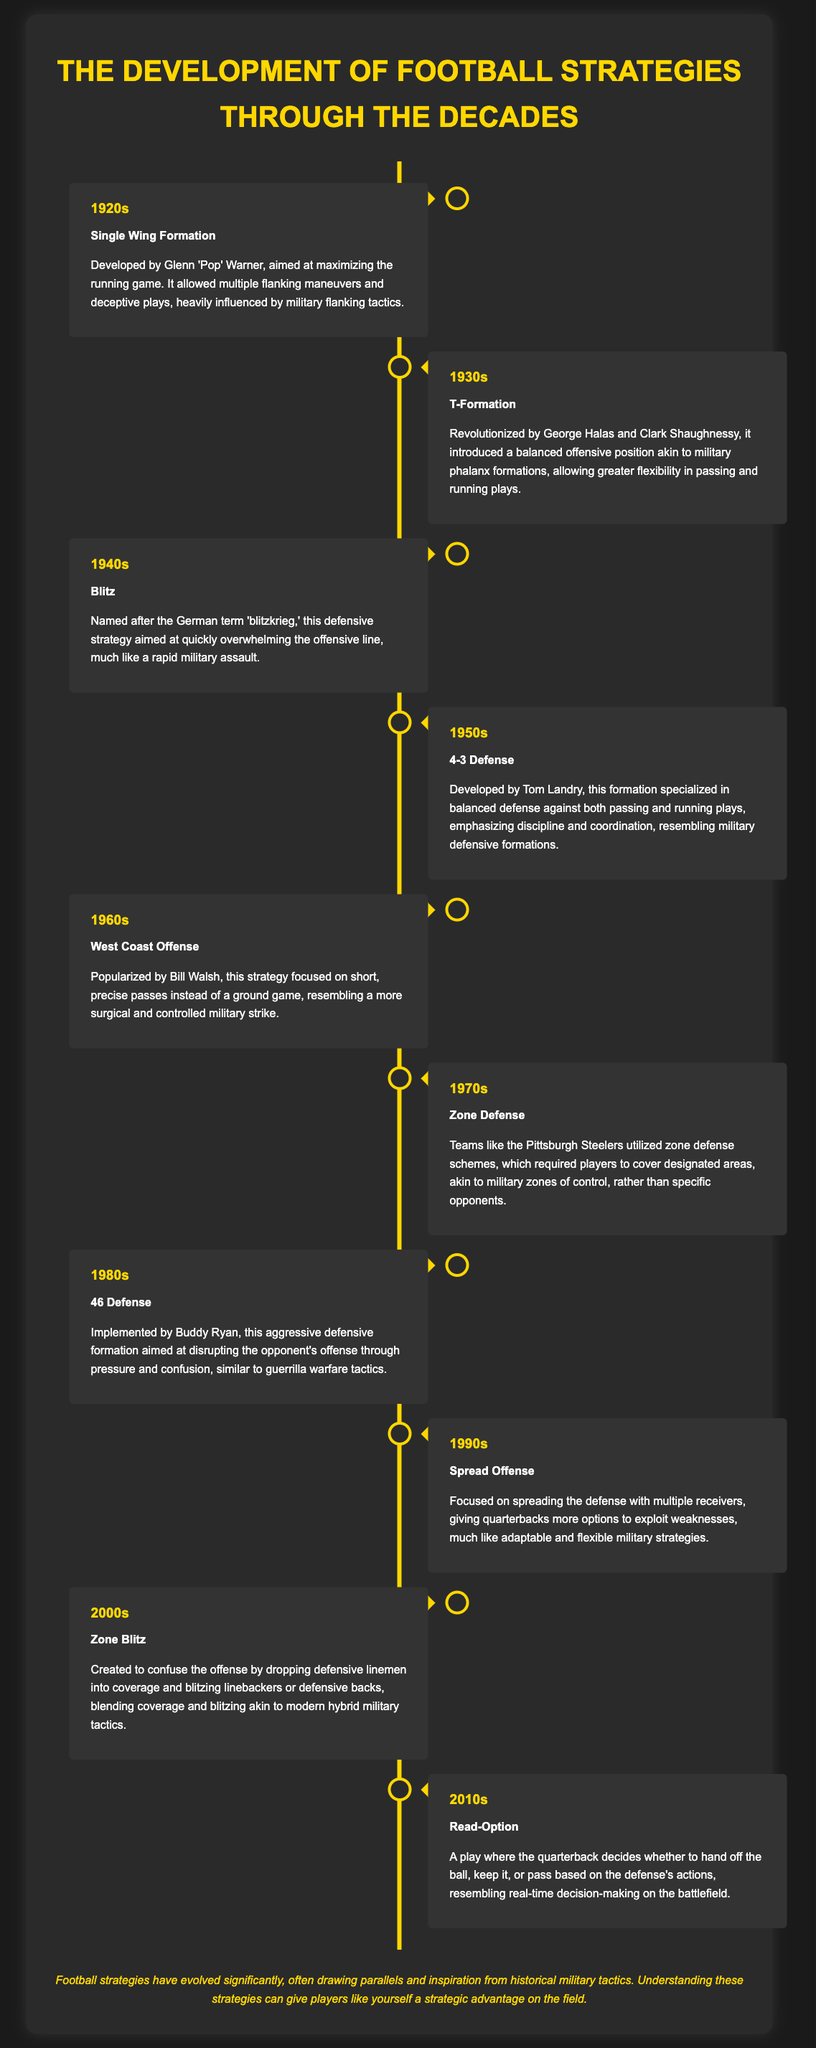What football strategy was developed in the 1920s? The 1920s featured the Single Wing Formation, which was aimed at maximizing the running game.
Answer: Single Wing Formation Who popularized the West Coast Offense? The document states that Bill Walsh popularized the West Coast Offense in the 1960s.
Answer: Bill Walsh What term describes the 1940s defensive strategy inspired by rapid military assault? The defensive strategy from the 1940s is known as the Blitz, which draws from the German term 'blitzkrieg.'
Answer: Blitz In which decade was the 4-3 Defense developed? The 4-3 Defense was developed in the 1950s as stated in the timeline.
Answer: 1950s What was a key feature of the Spread Offense in the 1990s? The Spread Offense focused on spreading the defense with multiple receivers.
Answer: Spreading the defense How does the Read-Option play relate to military strategy? The Read-Option involves real-time decision-making, similar to battlefield choices.
Answer: Real-time decision-making What does the term 'Zone Defense' refer to in the 1970s strategy? In the 1970s, Zone Defense refers to covering designated areas rather than specific players.
Answer: Covering designated areas What was the main advantage of the T-Formation in the 1930s? The T-Formation introduced a balanced offensive position allowing greater flexibility in plays.
Answer: Greater flexibility What type of offensive strategy did the 2000s introduce? The 2000s introduced the Zone Blitz strategy to confuse offenses.
Answer: Zone Blitz 